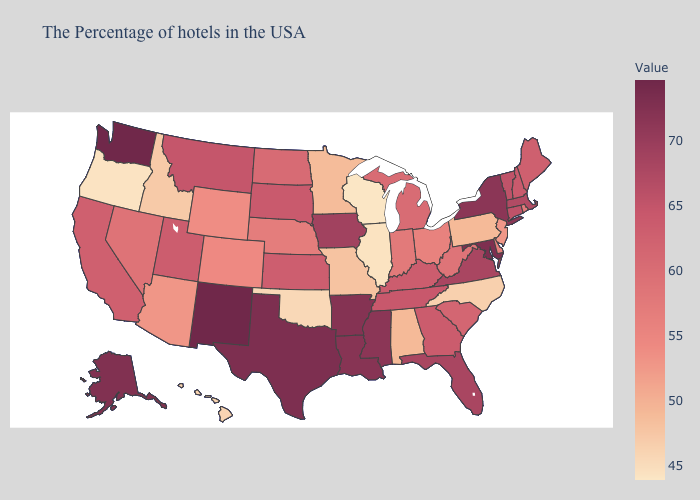Among the states that border Washington , does Idaho have the highest value?
Keep it brief. Yes. Does California have the lowest value in the USA?
Answer briefly. No. Which states have the highest value in the USA?
Write a very short answer. New Mexico, Washington. Which states hav the highest value in the MidWest?
Concise answer only. Iowa. Among the states that border Oklahoma , which have the lowest value?
Be succinct. Missouri. Among the states that border Maryland , does West Virginia have the highest value?
Short answer required. No. Does Maine have the highest value in the USA?
Write a very short answer. No. Does New Hampshire have a higher value than Colorado?
Give a very brief answer. Yes. Does New Mexico have the lowest value in the USA?
Quick response, please. No. Does South Carolina have the highest value in the USA?
Short answer required. No. 